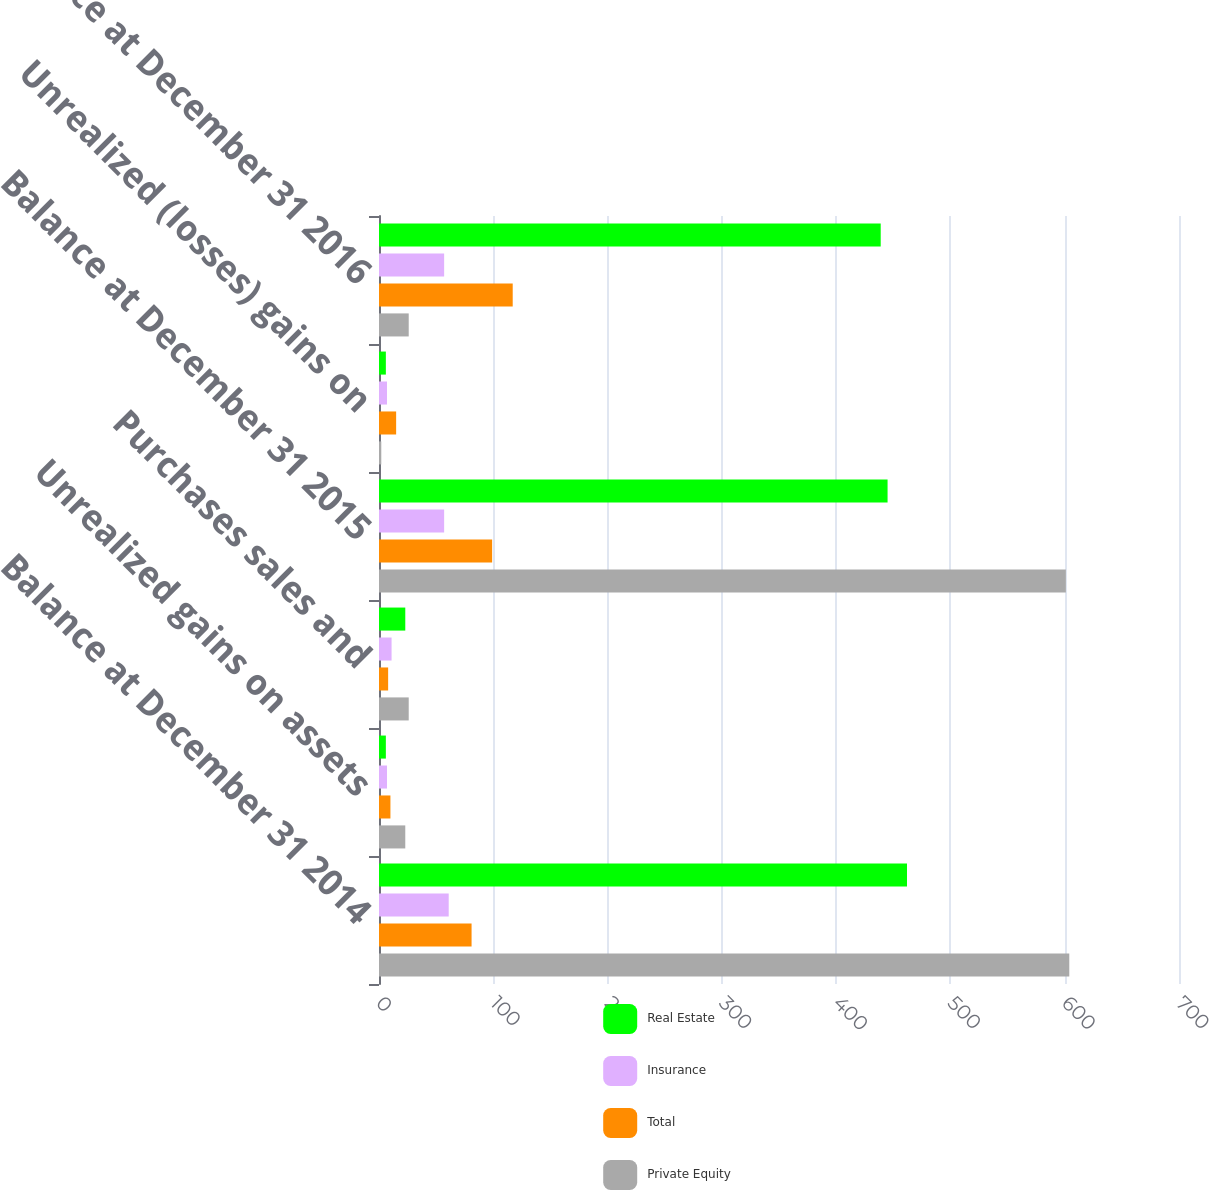Convert chart. <chart><loc_0><loc_0><loc_500><loc_500><stacked_bar_chart><ecel><fcel>Balance at December 31 2014<fcel>Unrealized gains on assets<fcel>Purchases sales and<fcel>Balance at December 31 2015<fcel>Unrealized (losses) gains on<fcel>Balance at December 31 2016<nl><fcel>Real Estate<fcel>462<fcel>6<fcel>23<fcel>445<fcel>6<fcel>439<nl><fcel>Insurance<fcel>61<fcel>7<fcel>11<fcel>57<fcel>7<fcel>57<nl><fcel>Total<fcel>81<fcel>10<fcel>8<fcel>99<fcel>15<fcel>117<nl><fcel>Private Equity<fcel>604<fcel>23<fcel>26<fcel>601<fcel>2<fcel>26<nl></chart> 